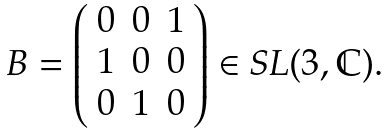Convert formula to latex. <formula><loc_0><loc_0><loc_500><loc_500>\begin{array} { l l l l l l l } B = \left ( \begin{array} { c c c } 0 & 0 & 1 \\ 1 & 0 & 0 \\ 0 & 1 & 0 \end{array} \right ) \in S L ( 3 , \mathbb { C } ) . \end{array}</formula> 